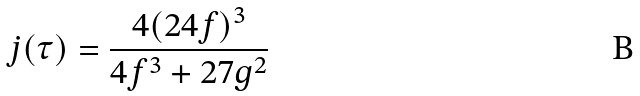<formula> <loc_0><loc_0><loc_500><loc_500>j ( \tau ) = \frac { 4 ( 2 4 f ) ^ { 3 } } { 4 f ^ { 3 } + 2 7 g ^ { 2 } }</formula> 